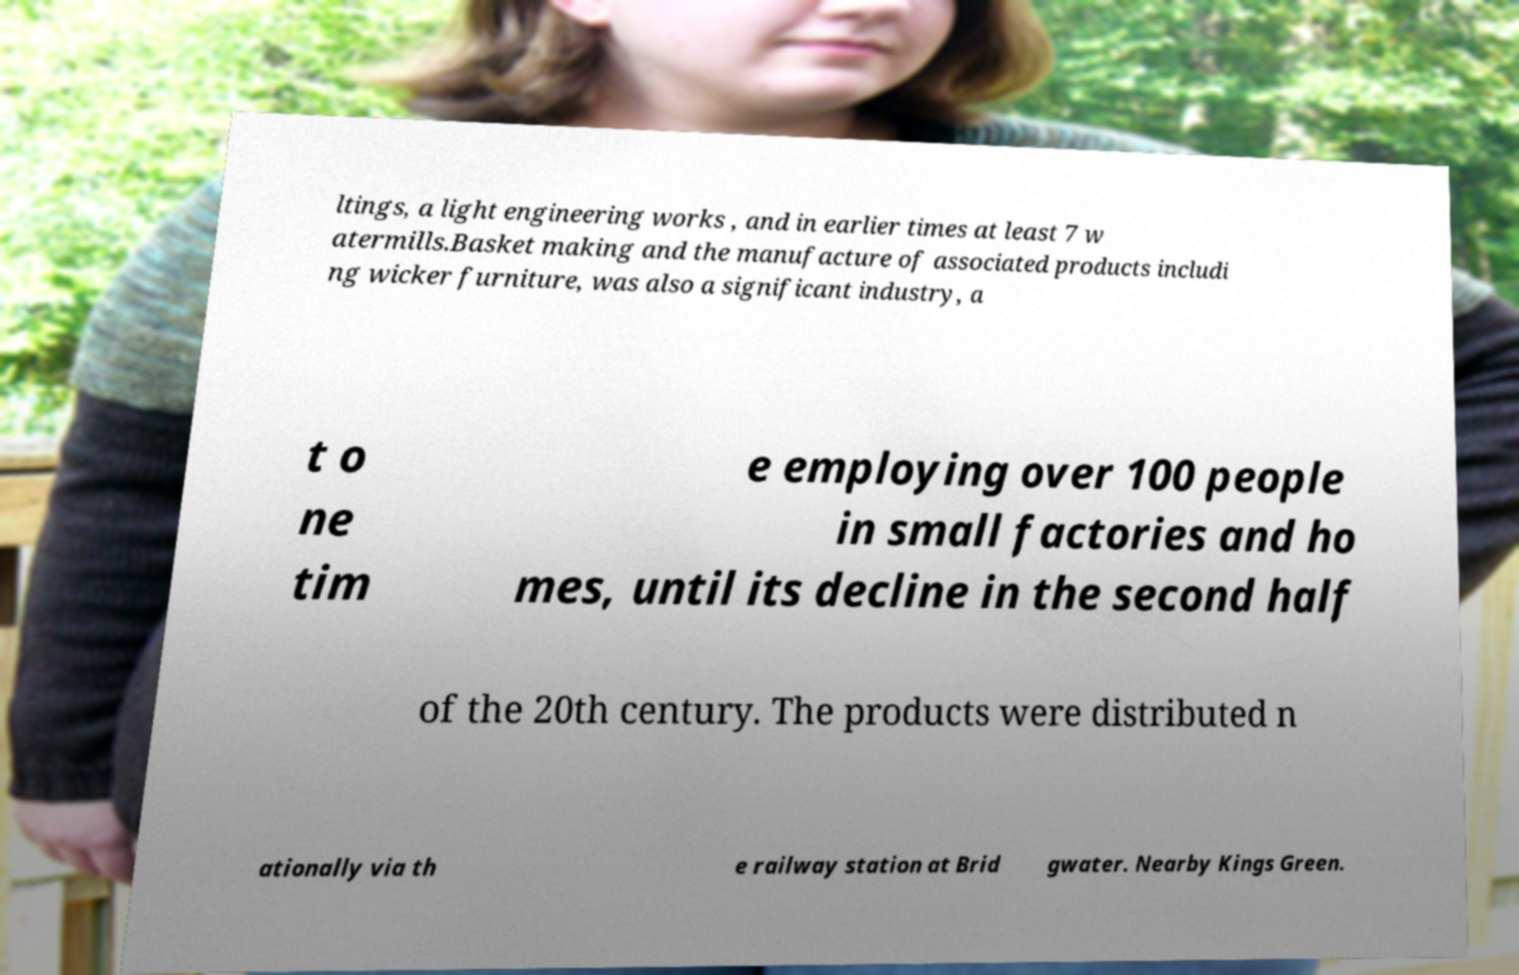Please identify and transcribe the text found in this image. ltings, a light engineering works , and in earlier times at least 7 w atermills.Basket making and the manufacture of associated products includi ng wicker furniture, was also a significant industry, a t o ne tim e employing over 100 people in small factories and ho mes, until its decline in the second half of the 20th century. The products were distributed n ationally via th e railway station at Brid gwater. Nearby Kings Green. 